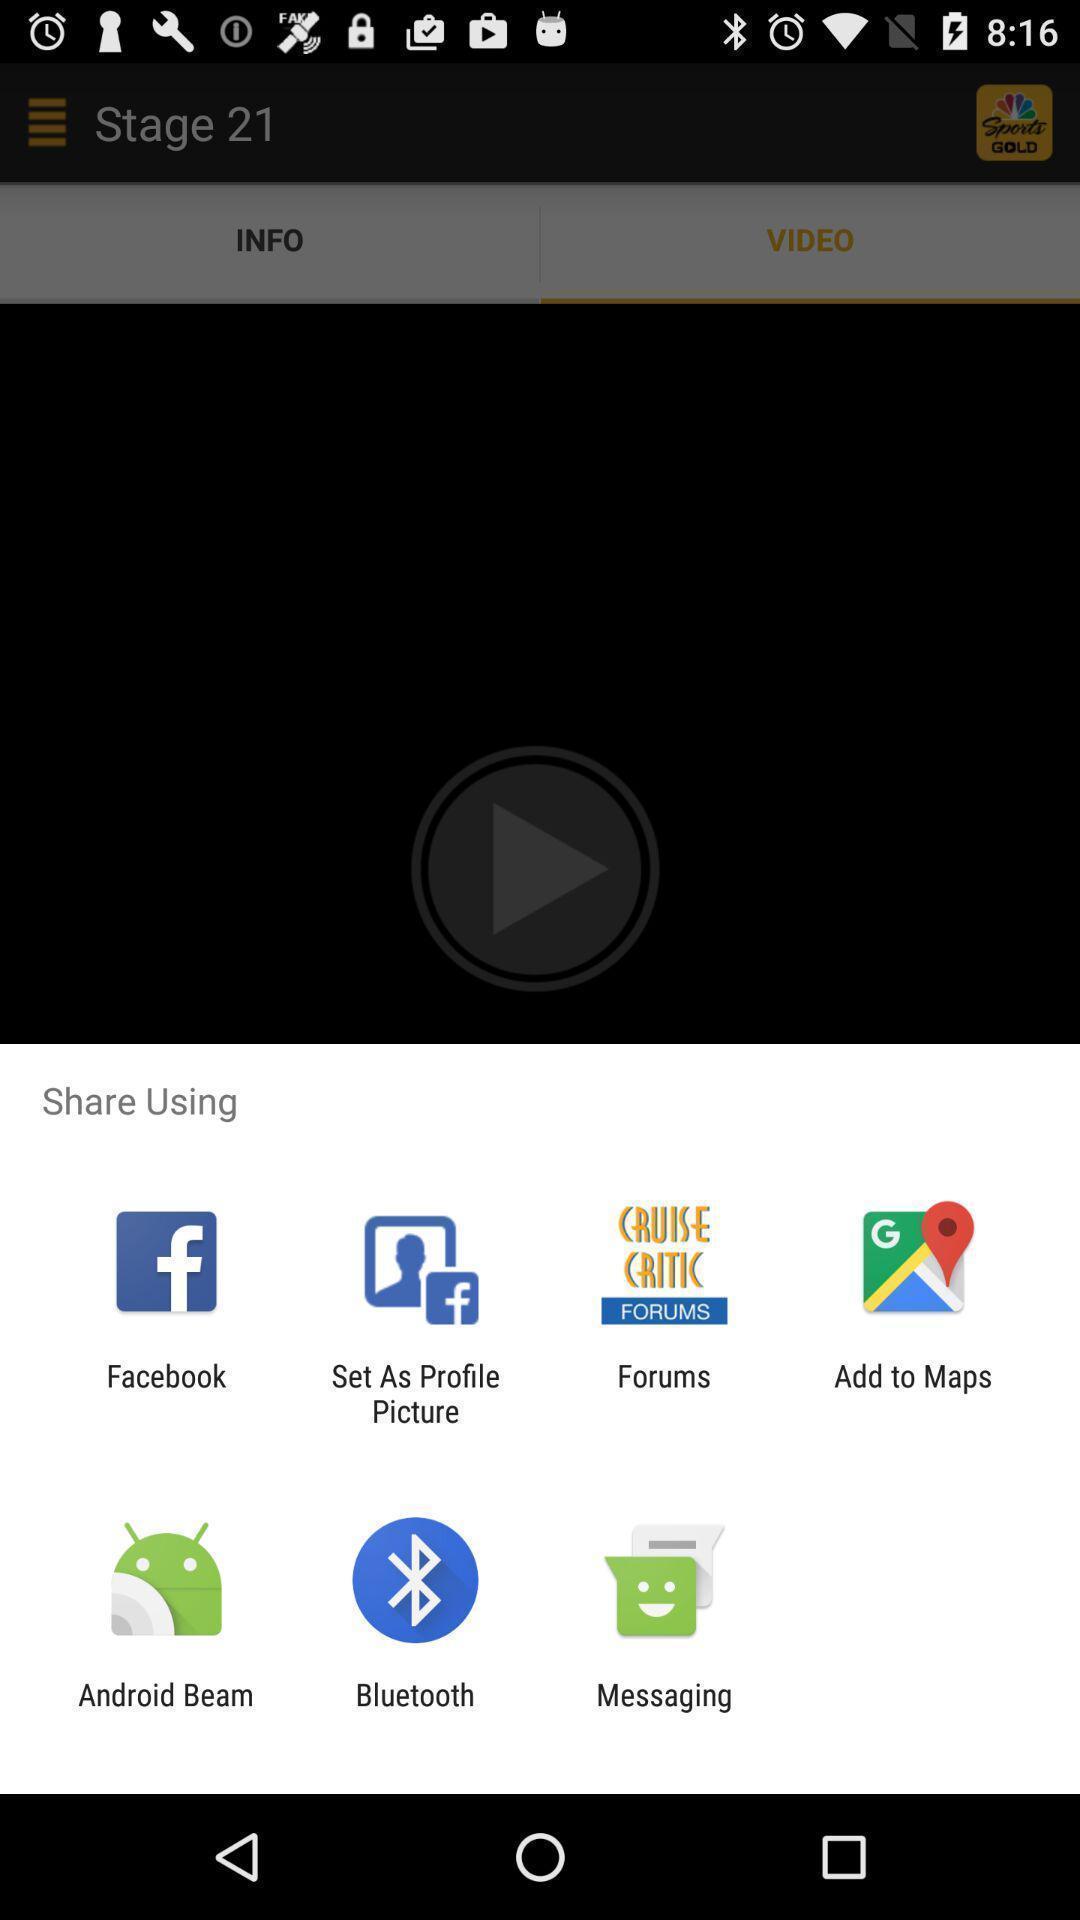What is the overall content of this screenshot? Pop-up to share using different apps. 